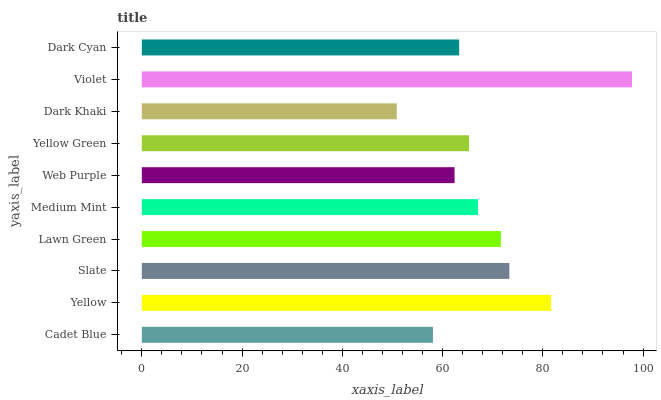Is Dark Khaki the minimum?
Answer yes or no. Yes. Is Violet the maximum?
Answer yes or no. Yes. Is Yellow the minimum?
Answer yes or no. No. Is Yellow the maximum?
Answer yes or no. No. Is Yellow greater than Cadet Blue?
Answer yes or no. Yes. Is Cadet Blue less than Yellow?
Answer yes or no. Yes. Is Cadet Blue greater than Yellow?
Answer yes or no. No. Is Yellow less than Cadet Blue?
Answer yes or no. No. Is Medium Mint the high median?
Answer yes or no. Yes. Is Yellow Green the low median?
Answer yes or no. Yes. Is Violet the high median?
Answer yes or no. No. Is Yellow the low median?
Answer yes or no. No. 